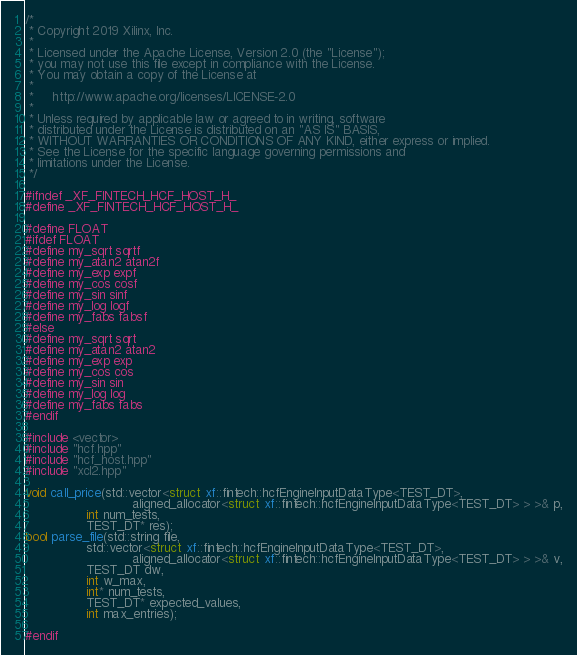<code> <loc_0><loc_0><loc_500><loc_500><_C++_>/*
 * Copyright 2019 Xilinx, Inc.
 *
 * Licensed under the Apache License, Version 2.0 (the "License");
 * you may not use this file except in compliance with the License.
 * You may obtain a copy of the License at
 *
 *     http://www.apache.org/licenses/LICENSE-2.0
 *
 * Unless required by applicable law or agreed to in writing, software
 * distributed under the License is distributed on an "AS IS" BASIS,
 * WITHOUT WARRANTIES OR CONDITIONS OF ANY KIND, either express or implied.
 * See the License for the specific language governing permissions and
 * limitations under the License.
 */

#ifndef _XF_FINTECH_HCF_HOST_H_
#define _XF_FINTECH_HCF_HOST_H_

#define FLOAT
#ifdef FLOAT
#define my_sqrt sqrtf
#define my_atan2 atan2f
#define my_exp expf
#define my_cos cosf
#define my_sin sinf
#define my_log logf
#define my_fabs fabsf
#else
#define my_sqrt sqrt
#define my_atan2 atan2
#define my_exp exp
#define my_cos cos
#define my_sin sin
#define my_log log
#define my_fabs fabs
#endif

#include <vector>
#include "hcf.hpp"
#include "hcf_host.hpp"
#include "xcl2.hpp"

void call_price(std::vector<struct xf::fintech::hcfEngineInputDataType<TEST_DT>,
                            aligned_allocator<struct xf::fintech::hcfEngineInputDataType<TEST_DT> > >& p,
                int num_tests,
                TEST_DT* res);
bool parse_file(std::string file,
                std::vector<struct xf::fintech::hcfEngineInputDataType<TEST_DT>,
                            aligned_allocator<struct xf::fintech::hcfEngineInputDataType<TEST_DT> > >& v,
                TEST_DT dw,
                int w_max,
                int* num_tests,
                TEST_DT* expected_values,
                int max_entries);

#endif
</code> 